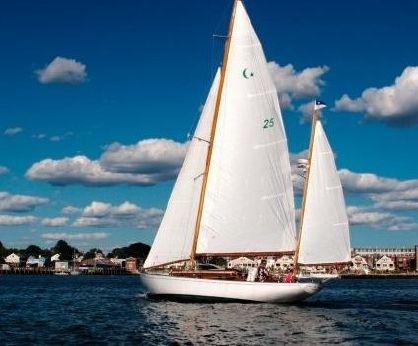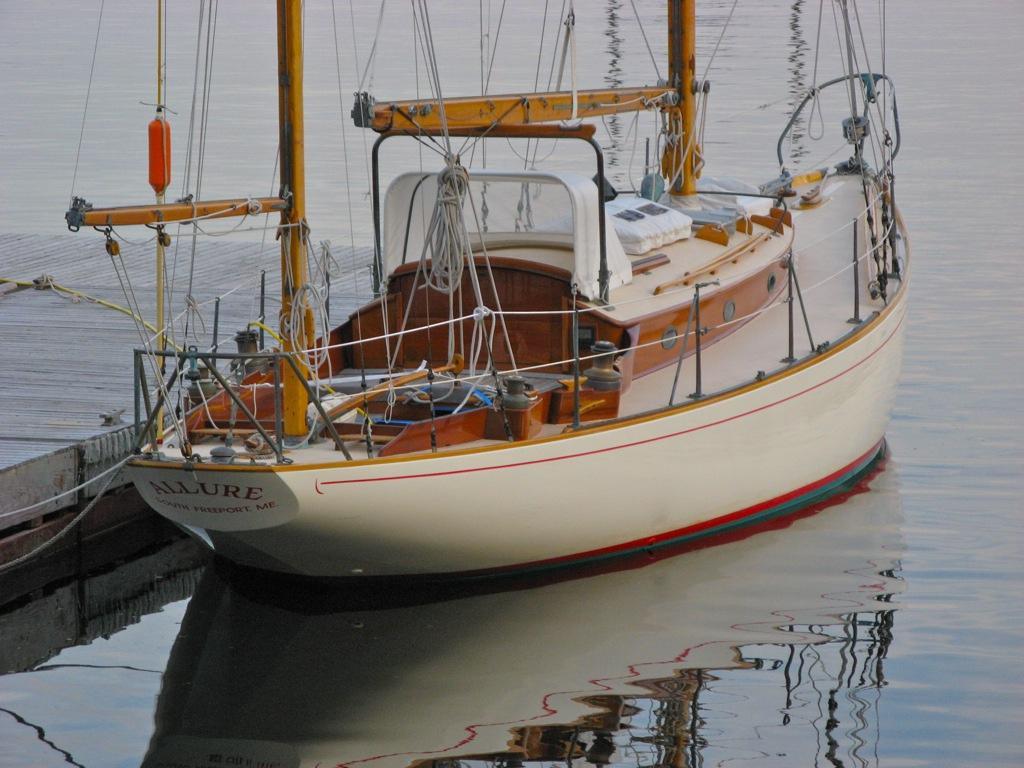The first image is the image on the left, the second image is the image on the right. Assess this claim about the two images: "The boat on the left doesn't have its sails up.". Correct or not? Answer yes or no. No. 